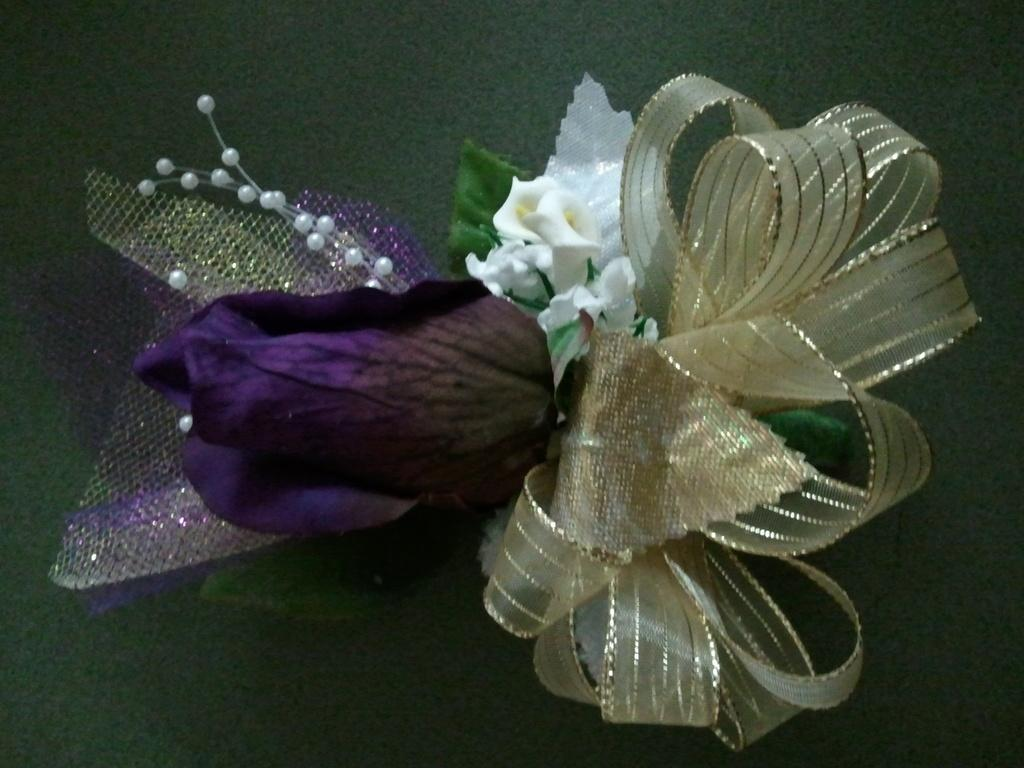What type of natural elements can be seen in the image? There are flowers and leaves in the image. What decorative elements are present in the image? There are ribbons and white pearls in the image. How are these elements arranged in the image? These elements are placed on a platform. How many cats can be seen wearing a veil in the image? There are no cats or veils present in the image. 